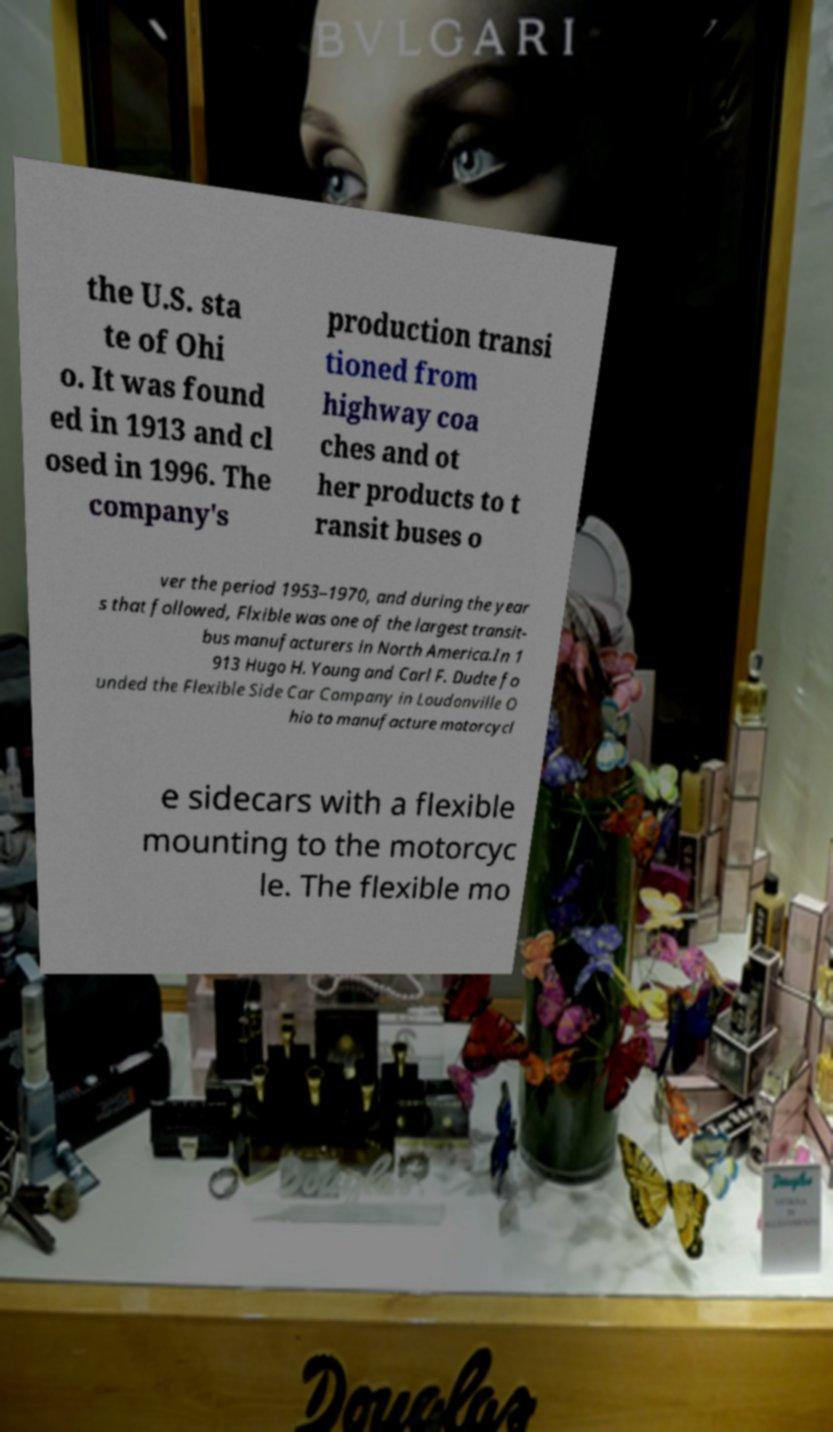I need the written content from this picture converted into text. Can you do that? the U.S. sta te of Ohi o. It was found ed in 1913 and cl osed in 1996. The company's production transi tioned from highway coa ches and ot her products to t ransit buses o ver the period 1953–1970, and during the year s that followed, Flxible was one of the largest transit- bus manufacturers in North America.In 1 913 Hugo H. Young and Carl F. Dudte fo unded the Flexible Side Car Company in Loudonville O hio to manufacture motorcycl e sidecars with a flexible mounting to the motorcyc le. The flexible mo 